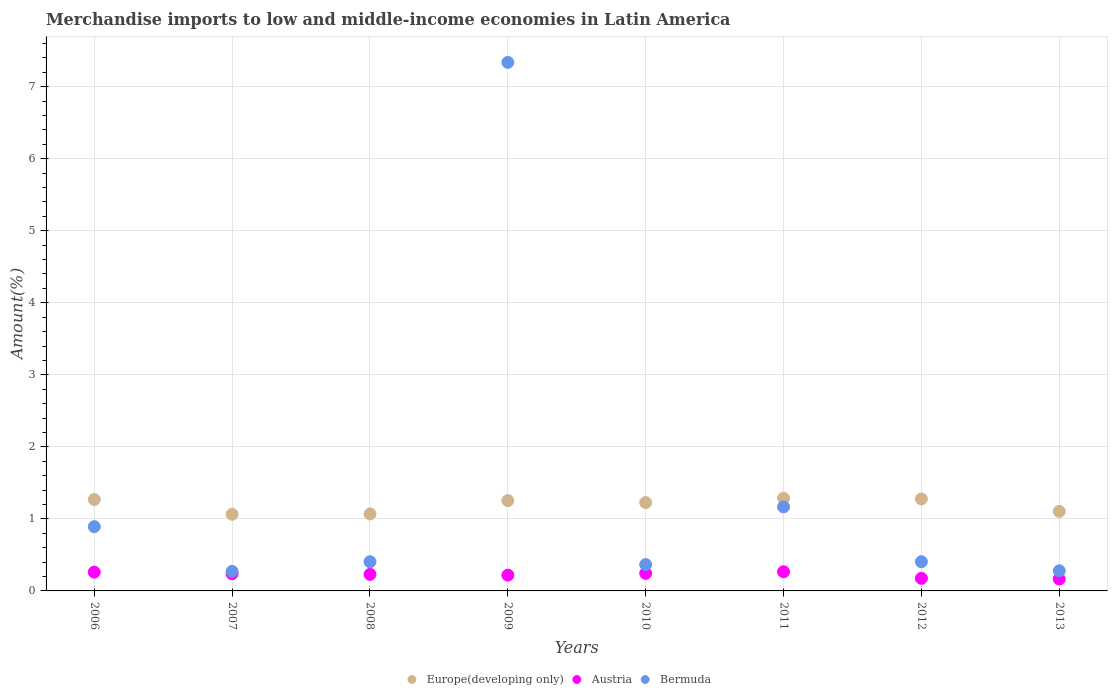What is the percentage of amount earned from merchandise imports in Austria in 2007?
Your answer should be compact. 0.24. Across all years, what is the maximum percentage of amount earned from merchandise imports in Europe(developing only)?
Offer a terse response. 1.29. Across all years, what is the minimum percentage of amount earned from merchandise imports in Bermuda?
Ensure brevity in your answer.  0.27. What is the total percentage of amount earned from merchandise imports in Europe(developing only) in the graph?
Offer a terse response. 9.55. What is the difference between the percentage of amount earned from merchandise imports in Austria in 2008 and that in 2012?
Offer a terse response. 0.06. What is the difference between the percentage of amount earned from merchandise imports in Austria in 2006 and the percentage of amount earned from merchandise imports in Europe(developing only) in 2008?
Your answer should be compact. -0.81. What is the average percentage of amount earned from merchandise imports in Europe(developing only) per year?
Offer a terse response. 1.19. In the year 2012, what is the difference between the percentage of amount earned from merchandise imports in Bermuda and percentage of amount earned from merchandise imports in Austria?
Ensure brevity in your answer.  0.23. What is the ratio of the percentage of amount earned from merchandise imports in Austria in 2006 to that in 2012?
Provide a succinct answer. 1.49. Is the percentage of amount earned from merchandise imports in Bermuda in 2011 less than that in 2012?
Make the answer very short. No. Is the difference between the percentage of amount earned from merchandise imports in Bermuda in 2009 and 2013 greater than the difference between the percentage of amount earned from merchandise imports in Austria in 2009 and 2013?
Your response must be concise. Yes. What is the difference between the highest and the second highest percentage of amount earned from merchandise imports in Bermuda?
Offer a very short reply. 6.17. What is the difference between the highest and the lowest percentage of amount earned from merchandise imports in Bermuda?
Offer a very short reply. 7.07. In how many years, is the percentage of amount earned from merchandise imports in Austria greater than the average percentage of amount earned from merchandise imports in Austria taken over all years?
Offer a very short reply. 5. Is the sum of the percentage of amount earned from merchandise imports in Bermuda in 2011 and 2013 greater than the maximum percentage of amount earned from merchandise imports in Europe(developing only) across all years?
Offer a terse response. Yes. Is it the case that in every year, the sum of the percentage of amount earned from merchandise imports in Austria and percentage of amount earned from merchandise imports in Europe(developing only)  is greater than the percentage of amount earned from merchandise imports in Bermuda?
Offer a very short reply. No. Does the percentage of amount earned from merchandise imports in Europe(developing only) monotonically increase over the years?
Provide a succinct answer. No. What is the difference between two consecutive major ticks on the Y-axis?
Your response must be concise. 1. Does the graph contain grids?
Give a very brief answer. Yes. Where does the legend appear in the graph?
Give a very brief answer. Bottom center. How many legend labels are there?
Your answer should be very brief. 3. How are the legend labels stacked?
Your answer should be compact. Horizontal. What is the title of the graph?
Keep it short and to the point. Merchandise imports to low and middle-income economies in Latin America. What is the label or title of the Y-axis?
Offer a terse response. Amount(%). What is the Amount(%) in Europe(developing only) in 2006?
Offer a terse response. 1.27. What is the Amount(%) of Austria in 2006?
Your answer should be compact. 0.26. What is the Amount(%) of Bermuda in 2006?
Give a very brief answer. 0.89. What is the Amount(%) in Europe(developing only) in 2007?
Give a very brief answer. 1.06. What is the Amount(%) in Austria in 2007?
Offer a very short reply. 0.24. What is the Amount(%) in Bermuda in 2007?
Ensure brevity in your answer.  0.27. What is the Amount(%) of Europe(developing only) in 2008?
Your answer should be compact. 1.07. What is the Amount(%) in Austria in 2008?
Keep it short and to the point. 0.23. What is the Amount(%) of Bermuda in 2008?
Offer a very short reply. 0.41. What is the Amount(%) of Europe(developing only) in 2009?
Provide a succinct answer. 1.25. What is the Amount(%) of Austria in 2009?
Offer a terse response. 0.22. What is the Amount(%) of Bermuda in 2009?
Offer a terse response. 7.34. What is the Amount(%) of Europe(developing only) in 2010?
Your response must be concise. 1.23. What is the Amount(%) of Austria in 2010?
Provide a succinct answer. 0.24. What is the Amount(%) of Bermuda in 2010?
Provide a short and direct response. 0.37. What is the Amount(%) in Europe(developing only) in 2011?
Offer a terse response. 1.29. What is the Amount(%) in Austria in 2011?
Your answer should be very brief. 0.27. What is the Amount(%) in Bermuda in 2011?
Offer a terse response. 1.17. What is the Amount(%) of Europe(developing only) in 2012?
Make the answer very short. 1.28. What is the Amount(%) of Austria in 2012?
Keep it short and to the point. 0.17. What is the Amount(%) of Bermuda in 2012?
Offer a very short reply. 0.41. What is the Amount(%) of Europe(developing only) in 2013?
Offer a very short reply. 1.1. What is the Amount(%) of Austria in 2013?
Make the answer very short. 0.17. What is the Amount(%) in Bermuda in 2013?
Offer a very short reply. 0.28. Across all years, what is the maximum Amount(%) of Europe(developing only)?
Make the answer very short. 1.29. Across all years, what is the maximum Amount(%) in Austria?
Your answer should be compact. 0.27. Across all years, what is the maximum Amount(%) in Bermuda?
Offer a very short reply. 7.34. Across all years, what is the minimum Amount(%) in Europe(developing only)?
Make the answer very short. 1.06. Across all years, what is the minimum Amount(%) in Austria?
Provide a short and direct response. 0.17. Across all years, what is the minimum Amount(%) in Bermuda?
Offer a very short reply. 0.27. What is the total Amount(%) in Europe(developing only) in the graph?
Offer a very short reply. 9.55. What is the total Amount(%) of Austria in the graph?
Make the answer very short. 1.8. What is the total Amount(%) of Bermuda in the graph?
Make the answer very short. 11.12. What is the difference between the Amount(%) in Europe(developing only) in 2006 and that in 2007?
Ensure brevity in your answer.  0.21. What is the difference between the Amount(%) in Austria in 2006 and that in 2007?
Ensure brevity in your answer.  0.02. What is the difference between the Amount(%) of Bermuda in 2006 and that in 2007?
Ensure brevity in your answer.  0.62. What is the difference between the Amount(%) in Europe(developing only) in 2006 and that in 2008?
Provide a succinct answer. 0.2. What is the difference between the Amount(%) in Austria in 2006 and that in 2008?
Make the answer very short. 0.03. What is the difference between the Amount(%) in Bermuda in 2006 and that in 2008?
Your response must be concise. 0.49. What is the difference between the Amount(%) in Europe(developing only) in 2006 and that in 2009?
Offer a terse response. 0.02. What is the difference between the Amount(%) in Austria in 2006 and that in 2009?
Give a very brief answer. 0.04. What is the difference between the Amount(%) of Bermuda in 2006 and that in 2009?
Offer a very short reply. -6.45. What is the difference between the Amount(%) in Europe(developing only) in 2006 and that in 2010?
Provide a short and direct response. 0.04. What is the difference between the Amount(%) of Austria in 2006 and that in 2010?
Offer a very short reply. 0.02. What is the difference between the Amount(%) of Bermuda in 2006 and that in 2010?
Offer a very short reply. 0.53. What is the difference between the Amount(%) of Europe(developing only) in 2006 and that in 2011?
Your response must be concise. -0.02. What is the difference between the Amount(%) in Austria in 2006 and that in 2011?
Your answer should be compact. -0. What is the difference between the Amount(%) of Bermuda in 2006 and that in 2011?
Ensure brevity in your answer.  -0.27. What is the difference between the Amount(%) in Europe(developing only) in 2006 and that in 2012?
Your answer should be very brief. -0.01. What is the difference between the Amount(%) of Austria in 2006 and that in 2012?
Offer a very short reply. 0.09. What is the difference between the Amount(%) of Bermuda in 2006 and that in 2012?
Your answer should be compact. 0.49. What is the difference between the Amount(%) of Europe(developing only) in 2006 and that in 2013?
Your answer should be very brief. 0.17. What is the difference between the Amount(%) in Austria in 2006 and that in 2013?
Offer a terse response. 0.1. What is the difference between the Amount(%) in Bermuda in 2006 and that in 2013?
Offer a very short reply. 0.61. What is the difference between the Amount(%) of Europe(developing only) in 2007 and that in 2008?
Provide a short and direct response. -0. What is the difference between the Amount(%) of Austria in 2007 and that in 2008?
Ensure brevity in your answer.  0.01. What is the difference between the Amount(%) of Bermuda in 2007 and that in 2008?
Keep it short and to the point. -0.13. What is the difference between the Amount(%) of Europe(developing only) in 2007 and that in 2009?
Make the answer very short. -0.19. What is the difference between the Amount(%) of Austria in 2007 and that in 2009?
Keep it short and to the point. 0.02. What is the difference between the Amount(%) of Bermuda in 2007 and that in 2009?
Give a very brief answer. -7.07. What is the difference between the Amount(%) of Europe(developing only) in 2007 and that in 2010?
Offer a terse response. -0.16. What is the difference between the Amount(%) of Austria in 2007 and that in 2010?
Give a very brief answer. -0.01. What is the difference between the Amount(%) of Bermuda in 2007 and that in 2010?
Keep it short and to the point. -0.09. What is the difference between the Amount(%) of Europe(developing only) in 2007 and that in 2011?
Your answer should be compact. -0.22. What is the difference between the Amount(%) of Austria in 2007 and that in 2011?
Ensure brevity in your answer.  -0.03. What is the difference between the Amount(%) in Bermuda in 2007 and that in 2011?
Your response must be concise. -0.9. What is the difference between the Amount(%) in Europe(developing only) in 2007 and that in 2012?
Your answer should be compact. -0.21. What is the difference between the Amount(%) of Austria in 2007 and that in 2012?
Keep it short and to the point. 0.06. What is the difference between the Amount(%) in Bermuda in 2007 and that in 2012?
Your answer should be compact. -0.13. What is the difference between the Amount(%) of Europe(developing only) in 2007 and that in 2013?
Provide a short and direct response. -0.04. What is the difference between the Amount(%) in Austria in 2007 and that in 2013?
Make the answer very short. 0.07. What is the difference between the Amount(%) of Bermuda in 2007 and that in 2013?
Keep it short and to the point. -0.01. What is the difference between the Amount(%) of Europe(developing only) in 2008 and that in 2009?
Your answer should be compact. -0.18. What is the difference between the Amount(%) of Austria in 2008 and that in 2009?
Offer a terse response. 0.01. What is the difference between the Amount(%) in Bermuda in 2008 and that in 2009?
Give a very brief answer. -6.93. What is the difference between the Amount(%) in Europe(developing only) in 2008 and that in 2010?
Make the answer very short. -0.16. What is the difference between the Amount(%) in Austria in 2008 and that in 2010?
Your answer should be compact. -0.01. What is the difference between the Amount(%) of Bermuda in 2008 and that in 2010?
Keep it short and to the point. 0.04. What is the difference between the Amount(%) in Europe(developing only) in 2008 and that in 2011?
Provide a succinct answer. -0.22. What is the difference between the Amount(%) in Austria in 2008 and that in 2011?
Ensure brevity in your answer.  -0.04. What is the difference between the Amount(%) in Bermuda in 2008 and that in 2011?
Offer a very short reply. -0.76. What is the difference between the Amount(%) in Europe(developing only) in 2008 and that in 2012?
Provide a short and direct response. -0.21. What is the difference between the Amount(%) in Austria in 2008 and that in 2012?
Give a very brief answer. 0.06. What is the difference between the Amount(%) in Bermuda in 2008 and that in 2012?
Your response must be concise. -0. What is the difference between the Amount(%) in Europe(developing only) in 2008 and that in 2013?
Offer a very short reply. -0.04. What is the difference between the Amount(%) in Austria in 2008 and that in 2013?
Your answer should be compact. 0.06. What is the difference between the Amount(%) of Bermuda in 2008 and that in 2013?
Keep it short and to the point. 0.13. What is the difference between the Amount(%) of Europe(developing only) in 2009 and that in 2010?
Offer a very short reply. 0.03. What is the difference between the Amount(%) in Austria in 2009 and that in 2010?
Your answer should be compact. -0.03. What is the difference between the Amount(%) in Bermuda in 2009 and that in 2010?
Provide a short and direct response. 6.97. What is the difference between the Amount(%) of Europe(developing only) in 2009 and that in 2011?
Your answer should be compact. -0.03. What is the difference between the Amount(%) of Austria in 2009 and that in 2011?
Make the answer very short. -0.05. What is the difference between the Amount(%) of Bermuda in 2009 and that in 2011?
Provide a succinct answer. 6.17. What is the difference between the Amount(%) in Europe(developing only) in 2009 and that in 2012?
Provide a short and direct response. -0.02. What is the difference between the Amount(%) in Austria in 2009 and that in 2012?
Your response must be concise. 0.04. What is the difference between the Amount(%) of Bermuda in 2009 and that in 2012?
Provide a short and direct response. 6.93. What is the difference between the Amount(%) in Europe(developing only) in 2009 and that in 2013?
Offer a very short reply. 0.15. What is the difference between the Amount(%) in Austria in 2009 and that in 2013?
Your answer should be compact. 0.05. What is the difference between the Amount(%) of Bermuda in 2009 and that in 2013?
Provide a succinct answer. 7.06. What is the difference between the Amount(%) of Europe(developing only) in 2010 and that in 2011?
Your answer should be very brief. -0.06. What is the difference between the Amount(%) in Austria in 2010 and that in 2011?
Offer a terse response. -0.02. What is the difference between the Amount(%) in Bermuda in 2010 and that in 2011?
Ensure brevity in your answer.  -0.8. What is the difference between the Amount(%) in Europe(developing only) in 2010 and that in 2012?
Offer a very short reply. -0.05. What is the difference between the Amount(%) of Austria in 2010 and that in 2012?
Provide a succinct answer. 0.07. What is the difference between the Amount(%) of Bermuda in 2010 and that in 2012?
Offer a terse response. -0.04. What is the difference between the Amount(%) in Europe(developing only) in 2010 and that in 2013?
Ensure brevity in your answer.  0.12. What is the difference between the Amount(%) in Austria in 2010 and that in 2013?
Make the answer very short. 0.08. What is the difference between the Amount(%) in Bermuda in 2010 and that in 2013?
Make the answer very short. 0.09. What is the difference between the Amount(%) of Europe(developing only) in 2011 and that in 2012?
Your answer should be compact. 0.01. What is the difference between the Amount(%) of Austria in 2011 and that in 2012?
Ensure brevity in your answer.  0.09. What is the difference between the Amount(%) of Bermuda in 2011 and that in 2012?
Ensure brevity in your answer.  0.76. What is the difference between the Amount(%) of Europe(developing only) in 2011 and that in 2013?
Provide a short and direct response. 0.18. What is the difference between the Amount(%) in Austria in 2011 and that in 2013?
Your response must be concise. 0.1. What is the difference between the Amount(%) of Bermuda in 2011 and that in 2013?
Keep it short and to the point. 0.89. What is the difference between the Amount(%) in Europe(developing only) in 2012 and that in 2013?
Ensure brevity in your answer.  0.17. What is the difference between the Amount(%) in Austria in 2012 and that in 2013?
Keep it short and to the point. 0.01. What is the difference between the Amount(%) of Bermuda in 2012 and that in 2013?
Make the answer very short. 0.13. What is the difference between the Amount(%) of Europe(developing only) in 2006 and the Amount(%) of Austria in 2007?
Your answer should be compact. 1.03. What is the difference between the Amount(%) in Europe(developing only) in 2006 and the Amount(%) in Bermuda in 2007?
Give a very brief answer. 1. What is the difference between the Amount(%) in Austria in 2006 and the Amount(%) in Bermuda in 2007?
Keep it short and to the point. -0.01. What is the difference between the Amount(%) in Europe(developing only) in 2006 and the Amount(%) in Austria in 2008?
Ensure brevity in your answer.  1.04. What is the difference between the Amount(%) in Europe(developing only) in 2006 and the Amount(%) in Bermuda in 2008?
Make the answer very short. 0.86. What is the difference between the Amount(%) in Austria in 2006 and the Amount(%) in Bermuda in 2008?
Your response must be concise. -0.14. What is the difference between the Amount(%) in Europe(developing only) in 2006 and the Amount(%) in Austria in 2009?
Keep it short and to the point. 1.05. What is the difference between the Amount(%) in Europe(developing only) in 2006 and the Amount(%) in Bermuda in 2009?
Provide a succinct answer. -6.07. What is the difference between the Amount(%) in Austria in 2006 and the Amount(%) in Bermuda in 2009?
Your answer should be very brief. -7.08. What is the difference between the Amount(%) in Europe(developing only) in 2006 and the Amount(%) in Austria in 2010?
Your answer should be very brief. 1.02. What is the difference between the Amount(%) of Europe(developing only) in 2006 and the Amount(%) of Bermuda in 2010?
Offer a very short reply. 0.9. What is the difference between the Amount(%) of Austria in 2006 and the Amount(%) of Bermuda in 2010?
Give a very brief answer. -0.1. What is the difference between the Amount(%) of Europe(developing only) in 2006 and the Amount(%) of Bermuda in 2011?
Your response must be concise. 0.1. What is the difference between the Amount(%) of Austria in 2006 and the Amount(%) of Bermuda in 2011?
Make the answer very short. -0.91. What is the difference between the Amount(%) of Europe(developing only) in 2006 and the Amount(%) of Austria in 2012?
Keep it short and to the point. 1.09. What is the difference between the Amount(%) of Europe(developing only) in 2006 and the Amount(%) of Bermuda in 2012?
Give a very brief answer. 0.86. What is the difference between the Amount(%) of Austria in 2006 and the Amount(%) of Bermuda in 2012?
Your answer should be very brief. -0.14. What is the difference between the Amount(%) in Europe(developing only) in 2006 and the Amount(%) in Austria in 2013?
Your answer should be compact. 1.1. What is the difference between the Amount(%) of Austria in 2006 and the Amount(%) of Bermuda in 2013?
Offer a very short reply. -0.02. What is the difference between the Amount(%) of Europe(developing only) in 2007 and the Amount(%) of Austria in 2008?
Offer a terse response. 0.83. What is the difference between the Amount(%) in Europe(developing only) in 2007 and the Amount(%) in Bermuda in 2008?
Keep it short and to the point. 0.66. What is the difference between the Amount(%) in Europe(developing only) in 2007 and the Amount(%) in Austria in 2009?
Provide a succinct answer. 0.85. What is the difference between the Amount(%) of Europe(developing only) in 2007 and the Amount(%) of Bermuda in 2009?
Offer a terse response. -6.27. What is the difference between the Amount(%) of Austria in 2007 and the Amount(%) of Bermuda in 2009?
Give a very brief answer. -7.1. What is the difference between the Amount(%) in Europe(developing only) in 2007 and the Amount(%) in Austria in 2010?
Ensure brevity in your answer.  0.82. What is the difference between the Amount(%) of Europe(developing only) in 2007 and the Amount(%) of Bermuda in 2010?
Keep it short and to the point. 0.7. What is the difference between the Amount(%) in Austria in 2007 and the Amount(%) in Bermuda in 2010?
Provide a succinct answer. -0.13. What is the difference between the Amount(%) in Europe(developing only) in 2007 and the Amount(%) in Austria in 2011?
Provide a succinct answer. 0.8. What is the difference between the Amount(%) in Europe(developing only) in 2007 and the Amount(%) in Bermuda in 2011?
Keep it short and to the point. -0.1. What is the difference between the Amount(%) of Austria in 2007 and the Amount(%) of Bermuda in 2011?
Offer a very short reply. -0.93. What is the difference between the Amount(%) of Europe(developing only) in 2007 and the Amount(%) of Austria in 2012?
Provide a short and direct response. 0.89. What is the difference between the Amount(%) of Europe(developing only) in 2007 and the Amount(%) of Bermuda in 2012?
Keep it short and to the point. 0.66. What is the difference between the Amount(%) of Austria in 2007 and the Amount(%) of Bermuda in 2012?
Keep it short and to the point. -0.17. What is the difference between the Amount(%) of Europe(developing only) in 2007 and the Amount(%) of Austria in 2013?
Provide a short and direct response. 0.9. What is the difference between the Amount(%) of Europe(developing only) in 2007 and the Amount(%) of Bermuda in 2013?
Your answer should be very brief. 0.78. What is the difference between the Amount(%) of Austria in 2007 and the Amount(%) of Bermuda in 2013?
Your response must be concise. -0.04. What is the difference between the Amount(%) of Europe(developing only) in 2008 and the Amount(%) of Austria in 2009?
Give a very brief answer. 0.85. What is the difference between the Amount(%) in Europe(developing only) in 2008 and the Amount(%) in Bermuda in 2009?
Offer a terse response. -6.27. What is the difference between the Amount(%) of Austria in 2008 and the Amount(%) of Bermuda in 2009?
Offer a very short reply. -7.11. What is the difference between the Amount(%) in Europe(developing only) in 2008 and the Amount(%) in Austria in 2010?
Give a very brief answer. 0.82. What is the difference between the Amount(%) of Europe(developing only) in 2008 and the Amount(%) of Bermuda in 2010?
Make the answer very short. 0.7. What is the difference between the Amount(%) in Austria in 2008 and the Amount(%) in Bermuda in 2010?
Your answer should be compact. -0.14. What is the difference between the Amount(%) in Europe(developing only) in 2008 and the Amount(%) in Austria in 2011?
Your answer should be very brief. 0.8. What is the difference between the Amount(%) in Europe(developing only) in 2008 and the Amount(%) in Bermuda in 2011?
Ensure brevity in your answer.  -0.1. What is the difference between the Amount(%) in Austria in 2008 and the Amount(%) in Bermuda in 2011?
Give a very brief answer. -0.94. What is the difference between the Amount(%) in Europe(developing only) in 2008 and the Amount(%) in Austria in 2012?
Give a very brief answer. 0.89. What is the difference between the Amount(%) in Europe(developing only) in 2008 and the Amount(%) in Bermuda in 2012?
Provide a short and direct response. 0.66. What is the difference between the Amount(%) of Austria in 2008 and the Amount(%) of Bermuda in 2012?
Your response must be concise. -0.18. What is the difference between the Amount(%) of Europe(developing only) in 2008 and the Amount(%) of Austria in 2013?
Provide a succinct answer. 0.9. What is the difference between the Amount(%) of Europe(developing only) in 2008 and the Amount(%) of Bermuda in 2013?
Offer a very short reply. 0.79. What is the difference between the Amount(%) in Austria in 2008 and the Amount(%) in Bermuda in 2013?
Offer a terse response. -0.05. What is the difference between the Amount(%) of Europe(developing only) in 2009 and the Amount(%) of Bermuda in 2010?
Your answer should be compact. 0.89. What is the difference between the Amount(%) in Austria in 2009 and the Amount(%) in Bermuda in 2010?
Your answer should be compact. -0.15. What is the difference between the Amount(%) of Europe(developing only) in 2009 and the Amount(%) of Austria in 2011?
Offer a very short reply. 0.99. What is the difference between the Amount(%) in Europe(developing only) in 2009 and the Amount(%) in Bermuda in 2011?
Give a very brief answer. 0.09. What is the difference between the Amount(%) in Austria in 2009 and the Amount(%) in Bermuda in 2011?
Offer a terse response. -0.95. What is the difference between the Amount(%) in Europe(developing only) in 2009 and the Amount(%) in Austria in 2012?
Your response must be concise. 1.08. What is the difference between the Amount(%) of Europe(developing only) in 2009 and the Amount(%) of Bermuda in 2012?
Your answer should be very brief. 0.85. What is the difference between the Amount(%) in Austria in 2009 and the Amount(%) in Bermuda in 2012?
Provide a short and direct response. -0.19. What is the difference between the Amount(%) of Europe(developing only) in 2009 and the Amount(%) of Austria in 2013?
Your answer should be compact. 1.09. What is the difference between the Amount(%) of Europe(developing only) in 2009 and the Amount(%) of Bermuda in 2013?
Offer a very short reply. 0.97. What is the difference between the Amount(%) of Austria in 2009 and the Amount(%) of Bermuda in 2013?
Your response must be concise. -0.06. What is the difference between the Amount(%) in Europe(developing only) in 2010 and the Amount(%) in Austria in 2011?
Offer a terse response. 0.96. What is the difference between the Amount(%) in Europe(developing only) in 2010 and the Amount(%) in Bermuda in 2011?
Give a very brief answer. 0.06. What is the difference between the Amount(%) in Austria in 2010 and the Amount(%) in Bermuda in 2011?
Your answer should be compact. -0.92. What is the difference between the Amount(%) in Europe(developing only) in 2010 and the Amount(%) in Austria in 2012?
Your response must be concise. 1.05. What is the difference between the Amount(%) of Europe(developing only) in 2010 and the Amount(%) of Bermuda in 2012?
Ensure brevity in your answer.  0.82. What is the difference between the Amount(%) in Austria in 2010 and the Amount(%) in Bermuda in 2012?
Your response must be concise. -0.16. What is the difference between the Amount(%) in Europe(developing only) in 2010 and the Amount(%) in Austria in 2013?
Ensure brevity in your answer.  1.06. What is the difference between the Amount(%) in Europe(developing only) in 2010 and the Amount(%) in Bermuda in 2013?
Keep it short and to the point. 0.95. What is the difference between the Amount(%) in Austria in 2010 and the Amount(%) in Bermuda in 2013?
Your answer should be compact. -0.03. What is the difference between the Amount(%) in Europe(developing only) in 2011 and the Amount(%) in Austria in 2012?
Your answer should be very brief. 1.11. What is the difference between the Amount(%) of Europe(developing only) in 2011 and the Amount(%) of Bermuda in 2012?
Ensure brevity in your answer.  0.88. What is the difference between the Amount(%) in Austria in 2011 and the Amount(%) in Bermuda in 2012?
Your answer should be compact. -0.14. What is the difference between the Amount(%) of Europe(developing only) in 2011 and the Amount(%) of Austria in 2013?
Your response must be concise. 1.12. What is the difference between the Amount(%) in Europe(developing only) in 2011 and the Amount(%) in Bermuda in 2013?
Your answer should be compact. 1.01. What is the difference between the Amount(%) in Austria in 2011 and the Amount(%) in Bermuda in 2013?
Provide a short and direct response. -0.01. What is the difference between the Amount(%) in Europe(developing only) in 2012 and the Amount(%) in Austria in 2013?
Provide a succinct answer. 1.11. What is the difference between the Amount(%) of Austria in 2012 and the Amount(%) of Bermuda in 2013?
Offer a terse response. -0.1. What is the average Amount(%) in Europe(developing only) per year?
Provide a short and direct response. 1.19. What is the average Amount(%) of Austria per year?
Ensure brevity in your answer.  0.22. What is the average Amount(%) of Bermuda per year?
Ensure brevity in your answer.  1.39. In the year 2006, what is the difference between the Amount(%) of Europe(developing only) and Amount(%) of Austria?
Give a very brief answer. 1.01. In the year 2006, what is the difference between the Amount(%) of Europe(developing only) and Amount(%) of Bermuda?
Your answer should be very brief. 0.38. In the year 2006, what is the difference between the Amount(%) in Austria and Amount(%) in Bermuda?
Provide a short and direct response. -0.63. In the year 2007, what is the difference between the Amount(%) of Europe(developing only) and Amount(%) of Austria?
Your response must be concise. 0.83. In the year 2007, what is the difference between the Amount(%) in Europe(developing only) and Amount(%) in Bermuda?
Make the answer very short. 0.79. In the year 2007, what is the difference between the Amount(%) of Austria and Amount(%) of Bermuda?
Offer a terse response. -0.03. In the year 2008, what is the difference between the Amount(%) in Europe(developing only) and Amount(%) in Austria?
Offer a very short reply. 0.84. In the year 2008, what is the difference between the Amount(%) in Europe(developing only) and Amount(%) in Bermuda?
Provide a succinct answer. 0.66. In the year 2008, what is the difference between the Amount(%) in Austria and Amount(%) in Bermuda?
Give a very brief answer. -0.18. In the year 2009, what is the difference between the Amount(%) in Europe(developing only) and Amount(%) in Austria?
Make the answer very short. 1.03. In the year 2009, what is the difference between the Amount(%) of Europe(developing only) and Amount(%) of Bermuda?
Ensure brevity in your answer.  -6.08. In the year 2009, what is the difference between the Amount(%) in Austria and Amount(%) in Bermuda?
Keep it short and to the point. -7.12. In the year 2010, what is the difference between the Amount(%) in Europe(developing only) and Amount(%) in Austria?
Provide a short and direct response. 0.98. In the year 2010, what is the difference between the Amount(%) of Europe(developing only) and Amount(%) of Bermuda?
Keep it short and to the point. 0.86. In the year 2010, what is the difference between the Amount(%) of Austria and Amount(%) of Bermuda?
Ensure brevity in your answer.  -0.12. In the year 2011, what is the difference between the Amount(%) in Europe(developing only) and Amount(%) in Austria?
Make the answer very short. 1.02. In the year 2011, what is the difference between the Amount(%) in Europe(developing only) and Amount(%) in Bermuda?
Offer a terse response. 0.12. In the year 2011, what is the difference between the Amount(%) in Austria and Amount(%) in Bermuda?
Keep it short and to the point. -0.9. In the year 2012, what is the difference between the Amount(%) of Europe(developing only) and Amount(%) of Austria?
Your answer should be very brief. 1.1. In the year 2012, what is the difference between the Amount(%) of Europe(developing only) and Amount(%) of Bermuda?
Offer a very short reply. 0.87. In the year 2012, what is the difference between the Amount(%) in Austria and Amount(%) in Bermuda?
Keep it short and to the point. -0.23. In the year 2013, what is the difference between the Amount(%) of Europe(developing only) and Amount(%) of Austria?
Offer a very short reply. 0.94. In the year 2013, what is the difference between the Amount(%) in Europe(developing only) and Amount(%) in Bermuda?
Your response must be concise. 0.82. In the year 2013, what is the difference between the Amount(%) of Austria and Amount(%) of Bermuda?
Keep it short and to the point. -0.11. What is the ratio of the Amount(%) in Europe(developing only) in 2006 to that in 2007?
Your response must be concise. 1.19. What is the ratio of the Amount(%) in Austria in 2006 to that in 2007?
Keep it short and to the point. 1.09. What is the ratio of the Amount(%) in Bermuda in 2006 to that in 2007?
Ensure brevity in your answer.  3.29. What is the ratio of the Amount(%) of Europe(developing only) in 2006 to that in 2008?
Your answer should be very brief. 1.19. What is the ratio of the Amount(%) of Austria in 2006 to that in 2008?
Offer a very short reply. 1.14. What is the ratio of the Amount(%) of Bermuda in 2006 to that in 2008?
Make the answer very short. 2.2. What is the ratio of the Amount(%) of Europe(developing only) in 2006 to that in 2009?
Your answer should be compact. 1.01. What is the ratio of the Amount(%) of Austria in 2006 to that in 2009?
Offer a very short reply. 1.19. What is the ratio of the Amount(%) of Bermuda in 2006 to that in 2009?
Make the answer very short. 0.12. What is the ratio of the Amount(%) of Europe(developing only) in 2006 to that in 2010?
Ensure brevity in your answer.  1.03. What is the ratio of the Amount(%) of Austria in 2006 to that in 2010?
Give a very brief answer. 1.07. What is the ratio of the Amount(%) in Bermuda in 2006 to that in 2010?
Offer a terse response. 2.44. What is the ratio of the Amount(%) in Europe(developing only) in 2006 to that in 2011?
Offer a very short reply. 0.99. What is the ratio of the Amount(%) of Austria in 2006 to that in 2011?
Keep it short and to the point. 0.98. What is the ratio of the Amount(%) in Bermuda in 2006 to that in 2011?
Ensure brevity in your answer.  0.76. What is the ratio of the Amount(%) in Austria in 2006 to that in 2012?
Give a very brief answer. 1.49. What is the ratio of the Amount(%) of Bermuda in 2006 to that in 2012?
Your answer should be compact. 2.2. What is the ratio of the Amount(%) in Europe(developing only) in 2006 to that in 2013?
Your answer should be very brief. 1.15. What is the ratio of the Amount(%) of Austria in 2006 to that in 2013?
Provide a succinct answer. 1.58. What is the ratio of the Amount(%) in Bermuda in 2006 to that in 2013?
Make the answer very short. 3.19. What is the ratio of the Amount(%) in Austria in 2007 to that in 2008?
Give a very brief answer. 1.04. What is the ratio of the Amount(%) of Bermuda in 2007 to that in 2008?
Offer a very short reply. 0.67. What is the ratio of the Amount(%) in Europe(developing only) in 2007 to that in 2009?
Offer a very short reply. 0.85. What is the ratio of the Amount(%) of Austria in 2007 to that in 2009?
Offer a very short reply. 1.09. What is the ratio of the Amount(%) in Bermuda in 2007 to that in 2009?
Offer a terse response. 0.04. What is the ratio of the Amount(%) in Europe(developing only) in 2007 to that in 2010?
Make the answer very short. 0.87. What is the ratio of the Amount(%) in Austria in 2007 to that in 2010?
Provide a short and direct response. 0.98. What is the ratio of the Amount(%) of Bermuda in 2007 to that in 2010?
Provide a succinct answer. 0.74. What is the ratio of the Amount(%) of Europe(developing only) in 2007 to that in 2011?
Your response must be concise. 0.83. What is the ratio of the Amount(%) of Austria in 2007 to that in 2011?
Provide a short and direct response. 0.9. What is the ratio of the Amount(%) in Bermuda in 2007 to that in 2011?
Your answer should be compact. 0.23. What is the ratio of the Amount(%) in Austria in 2007 to that in 2012?
Provide a succinct answer. 1.37. What is the ratio of the Amount(%) of Bermuda in 2007 to that in 2012?
Make the answer very short. 0.67. What is the ratio of the Amount(%) in Europe(developing only) in 2007 to that in 2013?
Your answer should be very brief. 0.96. What is the ratio of the Amount(%) in Austria in 2007 to that in 2013?
Your answer should be very brief. 1.44. What is the ratio of the Amount(%) in Bermuda in 2007 to that in 2013?
Give a very brief answer. 0.97. What is the ratio of the Amount(%) of Europe(developing only) in 2008 to that in 2009?
Provide a short and direct response. 0.85. What is the ratio of the Amount(%) of Austria in 2008 to that in 2009?
Keep it short and to the point. 1.05. What is the ratio of the Amount(%) of Bermuda in 2008 to that in 2009?
Your answer should be compact. 0.06. What is the ratio of the Amount(%) of Europe(developing only) in 2008 to that in 2010?
Offer a terse response. 0.87. What is the ratio of the Amount(%) of Austria in 2008 to that in 2010?
Provide a succinct answer. 0.94. What is the ratio of the Amount(%) in Bermuda in 2008 to that in 2010?
Give a very brief answer. 1.11. What is the ratio of the Amount(%) in Europe(developing only) in 2008 to that in 2011?
Give a very brief answer. 0.83. What is the ratio of the Amount(%) of Austria in 2008 to that in 2011?
Your answer should be very brief. 0.86. What is the ratio of the Amount(%) of Bermuda in 2008 to that in 2011?
Keep it short and to the point. 0.35. What is the ratio of the Amount(%) in Europe(developing only) in 2008 to that in 2012?
Keep it short and to the point. 0.84. What is the ratio of the Amount(%) of Austria in 2008 to that in 2012?
Provide a short and direct response. 1.32. What is the ratio of the Amount(%) in Europe(developing only) in 2008 to that in 2013?
Offer a very short reply. 0.97. What is the ratio of the Amount(%) of Austria in 2008 to that in 2013?
Provide a succinct answer. 1.39. What is the ratio of the Amount(%) of Bermuda in 2008 to that in 2013?
Your response must be concise. 1.45. What is the ratio of the Amount(%) of Europe(developing only) in 2009 to that in 2010?
Your answer should be very brief. 1.02. What is the ratio of the Amount(%) of Austria in 2009 to that in 2010?
Your response must be concise. 0.9. What is the ratio of the Amount(%) in Bermuda in 2009 to that in 2010?
Keep it short and to the point. 20.07. What is the ratio of the Amount(%) in Europe(developing only) in 2009 to that in 2011?
Your response must be concise. 0.97. What is the ratio of the Amount(%) in Austria in 2009 to that in 2011?
Give a very brief answer. 0.82. What is the ratio of the Amount(%) in Bermuda in 2009 to that in 2011?
Your answer should be compact. 6.29. What is the ratio of the Amount(%) of Europe(developing only) in 2009 to that in 2012?
Your answer should be compact. 0.98. What is the ratio of the Amount(%) in Austria in 2009 to that in 2012?
Your answer should be compact. 1.25. What is the ratio of the Amount(%) of Bermuda in 2009 to that in 2012?
Keep it short and to the point. 18.1. What is the ratio of the Amount(%) of Europe(developing only) in 2009 to that in 2013?
Your answer should be very brief. 1.14. What is the ratio of the Amount(%) of Austria in 2009 to that in 2013?
Offer a very short reply. 1.32. What is the ratio of the Amount(%) in Bermuda in 2009 to that in 2013?
Your answer should be compact. 26.26. What is the ratio of the Amount(%) in Europe(developing only) in 2010 to that in 2011?
Provide a succinct answer. 0.95. What is the ratio of the Amount(%) in Austria in 2010 to that in 2011?
Make the answer very short. 0.92. What is the ratio of the Amount(%) of Bermuda in 2010 to that in 2011?
Provide a short and direct response. 0.31. What is the ratio of the Amount(%) in Europe(developing only) in 2010 to that in 2012?
Make the answer very short. 0.96. What is the ratio of the Amount(%) in Austria in 2010 to that in 2012?
Give a very brief answer. 1.4. What is the ratio of the Amount(%) of Bermuda in 2010 to that in 2012?
Keep it short and to the point. 0.9. What is the ratio of the Amount(%) in Europe(developing only) in 2010 to that in 2013?
Your response must be concise. 1.11. What is the ratio of the Amount(%) in Austria in 2010 to that in 2013?
Offer a terse response. 1.48. What is the ratio of the Amount(%) in Bermuda in 2010 to that in 2013?
Make the answer very short. 1.31. What is the ratio of the Amount(%) of Europe(developing only) in 2011 to that in 2012?
Give a very brief answer. 1.01. What is the ratio of the Amount(%) in Austria in 2011 to that in 2012?
Ensure brevity in your answer.  1.52. What is the ratio of the Amount(%) of Bermuda in 2011 to that in 2012?
Provide a succinct answer. 2.88. What is the ratio of the Amount(%) in Europe(developing only) in 2011 to that in 2013?
Ensure brevity in your answer.  1.17. What is the ratio of the Amount(%) of Austria in 2011 to that in 2013?
Your answer should be compact. 1.61. What is the ratio of the Amount(%) of Bermuda in 2011 to that in 2013?
Your answer should be very brief. 4.18. What is the ratio of the Amount(%) in Europe(developing only) in 2012 to that in 2013?
Your answer should be compact. 1.16. What is the ratio of the Amount(%) of Austria in 2012 to that in 2013?
Ensure brevity in your answer.  1.06. What is the ratio of the Amount(%) in Bermuda in 2012 to that in 2013?
Keep it short and to the point. 1.45. What is the difference between the highest and the second highest Amount(%) of Europe(developing only)?
Ensure brevity in your answer.  0.01. What is the difference between the highest and the second highest Amount(%) of Austria?
Your response must be concise. 0. What is the difference between the highest and the second highest Amount(%) in Bermuda?
Keep it short and to the point. 6.17. What is the difference between the highest and the lowest Amount(%) of Europe(developing only)?
Your answer should be compact. 0.22. What is the difference between the highest and the lowest Amount(%) of Austria?
Make the answer very short. 0.1. What is the difference between the highest and the lowest Amount(%) in Bermuda?
Keep it short and to the point. 7.07. 